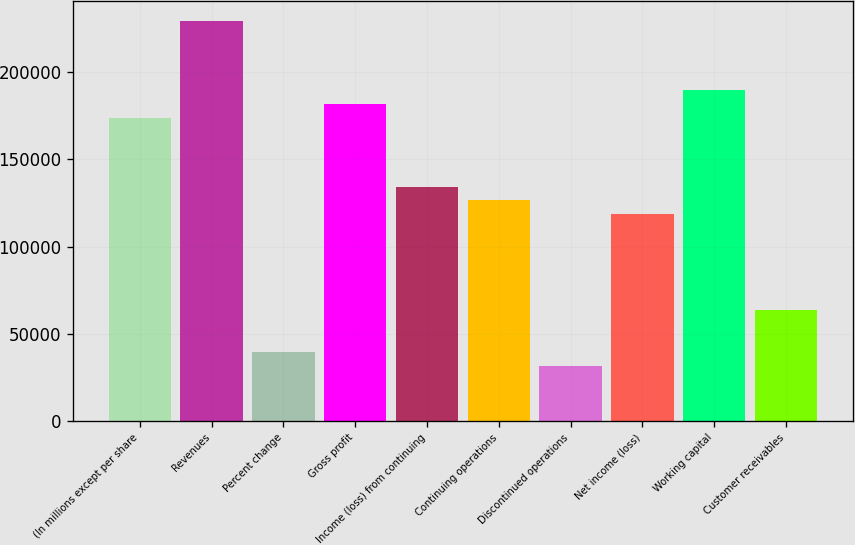Convert chart to OTSL. <chart><loc_0><loc_0><loc_500><loc_500><bar_chart><fcel>(In millions except per share<fcel>Revenues<fcel>Percent change<fcel>Gross profit<fcel>Income (loss) from continuing<fcel>Continuing operations<fcel>Discontinued operations<fcel>Net income (loss)<fcel>Working capital<fcel>Customer receivables<nl><fcel>174011<fcel>229378<fcel>39548.1<fcel>181921<fcel>134463<fcel>126554<fcel>31638.6<fcel>118644<fcel>189830<fcel>63276.9<nl></chart> 